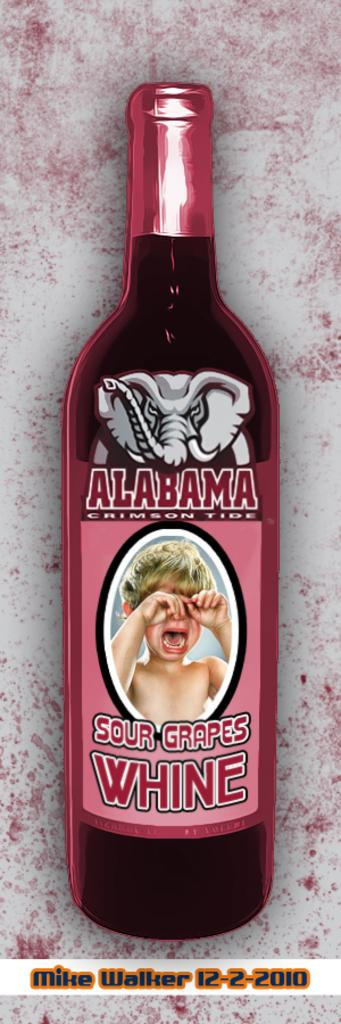What is the main object in the image? There is a wine bottle in the image. What can be seen on the wine bottle? There is text written on the wine bottle, as well as an elephant image and a crying boy image. What type of lipstick is the writer using in the image? There is no writer or lipstick present in the image; it features a wine bottle with text and images. 